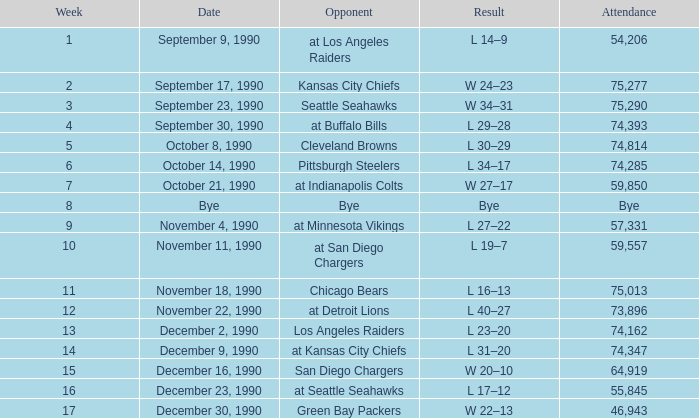Parse the full table. {'header': ['Week', 'Date', 'Opponent', 'Result', 'Attendance'], 'rows': [['1', 'September 9, 1990', 'at Los Angeles Raiders', 'L 14–9', '54,206'], ['2', 'September 17, 1990', 'Kansas City Chiefs', 'W 24–23', '75,277'], ['3', 'September 23, 1990', 'Seattle Seahawks', 'W 34–31', '75,290'], ['4', 'September 30, 1990', 'at Buffalo Bills', 'L 29–28', '74,393'], ['5', 'October 8, 1990', 'Cleveland Browns', 'L 30–29', '74,814'], ['6', 'October 14, 1990', 'Pittsburgh Steelers', 'L 34–17', '74,285'], ['7', 'October 21, 1990', 'at Indianapolis Colts', 'W 27–17', '59,850'], ['8', 'Bye', 'Bye', 'Bye', 'Bye'], ['9', 'November 4, 1990', 'at Minnesota Vikings', 'L 27–22', '57,331'], ['10', 'November 11, 1990', 'at San Diego Chargers', 'L 19–7', '59,557'], ['11', 'November 18, 1990', 'Chicago Bears', 'L 16–13', '75,013'], ['12', 'November 22, 1990', 'at Detroit Lions', 'L 40–27', '73,896'], ['13', 'December 2, 1990', 'Los Angeles Raiders', 'L 23–20', '74,162'], ['14', 'December 9, 1990', 'at Kansas City Chiefs', 'L 31–20', '74,347'], ['15', 'December 16, 1990', 'San Diego Chargers', 'W 20–10', '64,919'], ['16', 'December 23, 1990', 'at Seattle Seahawks', 'L 17–12', '55,845'], ['17', 'December 30, 1990', 'Green Bay Packers', 'W 22–13', '46,943']]} With an attendance of 57,331, which team is being faced as the adversary? At minnesota vikings. 